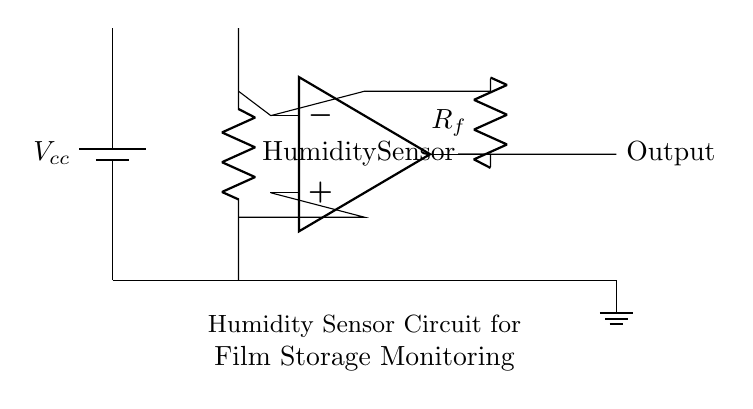What is the main component used for humidity sensing? The main component responsible for humidity sensing in this circuit is the humidity sensor, as indicated in the diagram. Its primary function is to detect and measure the moisture in the air.
Answer: Humidity Sensor What is the purpose of the operational amplifier in this circuit? The operational amplifier is used to amplify the voltage signal from the humidity sensor, ensuring that the output signal is strong enough for monitoring purposes. The op-amp takes inputs from the sensor and provides a corresponding output that reflects humidity levels.
Answer: Amplification What is connected to the output of the operational amplifier? The output of the operational amplifier is connected to the output node labeled "Output," which is where the amplified signal will be taken for monitoring or further processing.
Answer: Output What is the role of the feedback resistor in this circuit? The feedback resistor is used to control the gain of the operational amplifier, which determines how much the input signal from the humidity sensor will be amplified. It forms a feedback loop with the op-amp, setting the circuit's response.
Answer: Gain control What can happen if the humidity sensor malfunctions? If the humidity sensor malfunctions, it may produce an incorrect voltage signal, leading to faulty monitoring of environmental conditions in the film storage area, which could result in potential damage to the stored film reels.
Answer: Incorrect readings Which components are powered by the power supply? The humidity sensor and the operational amplifier are powered by the power supply, as they require voltage to function and process the humidity measurements in the circuit setup.
Answer: Humidity sensor and operational amplifier 